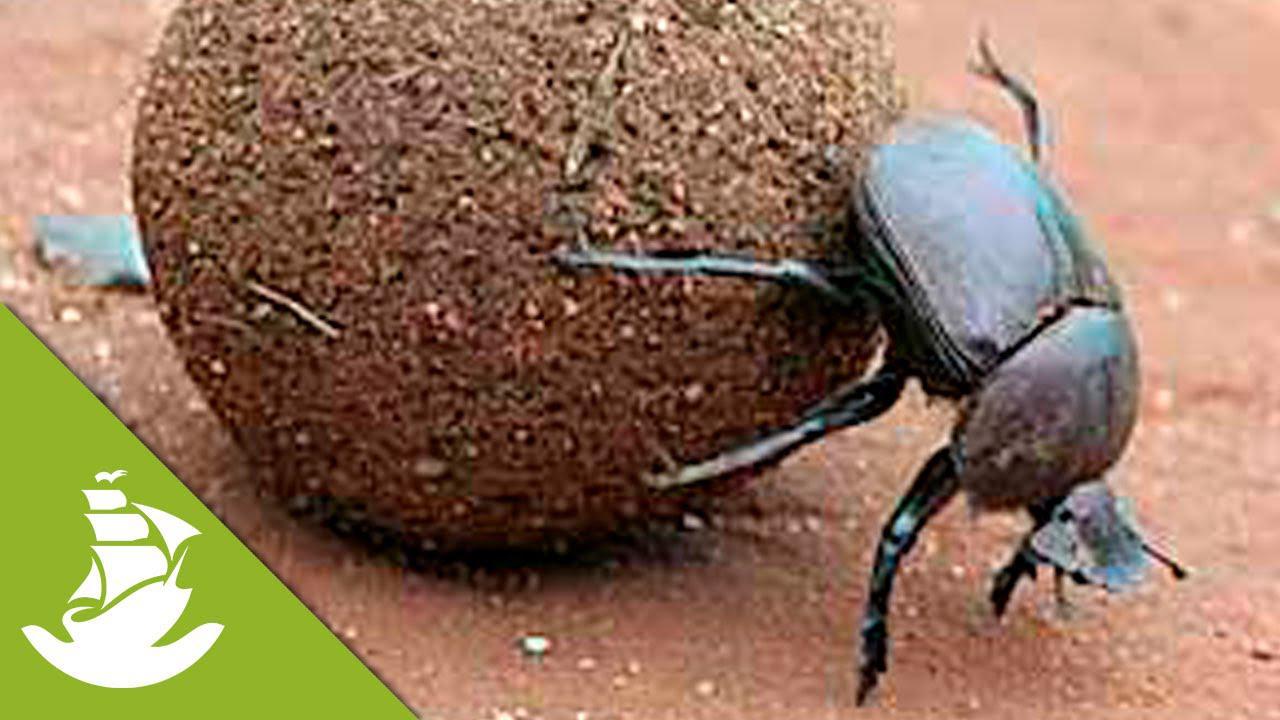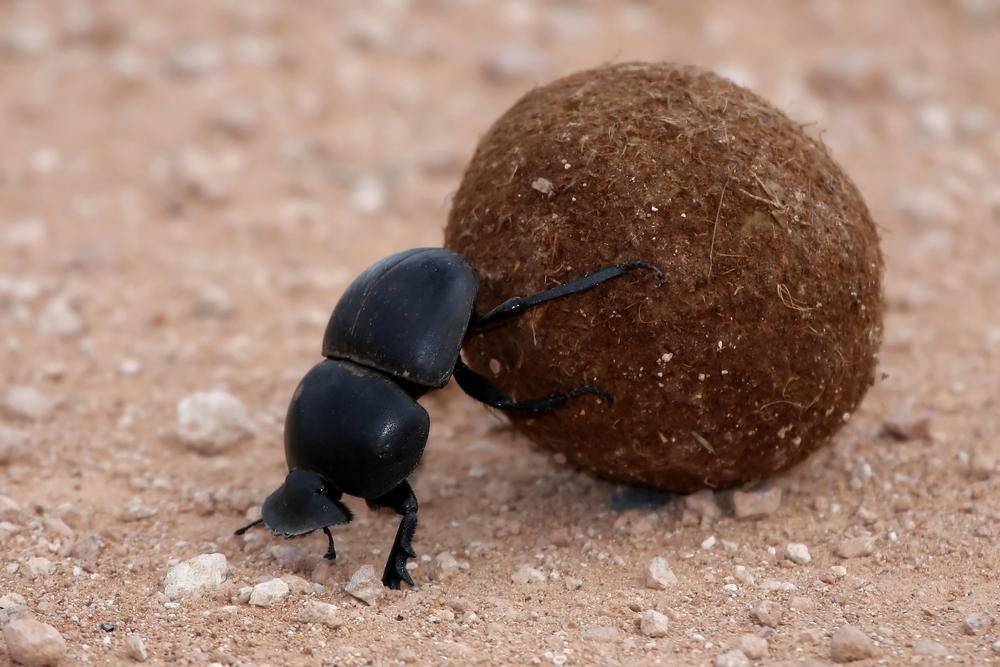The first image is the image on the left, the second image is the image on the right. Evaluate the accuracy of this statement regarding the images: "One image does not include a dungball with the beetle.". Is it true? Answer yes or no. No. 